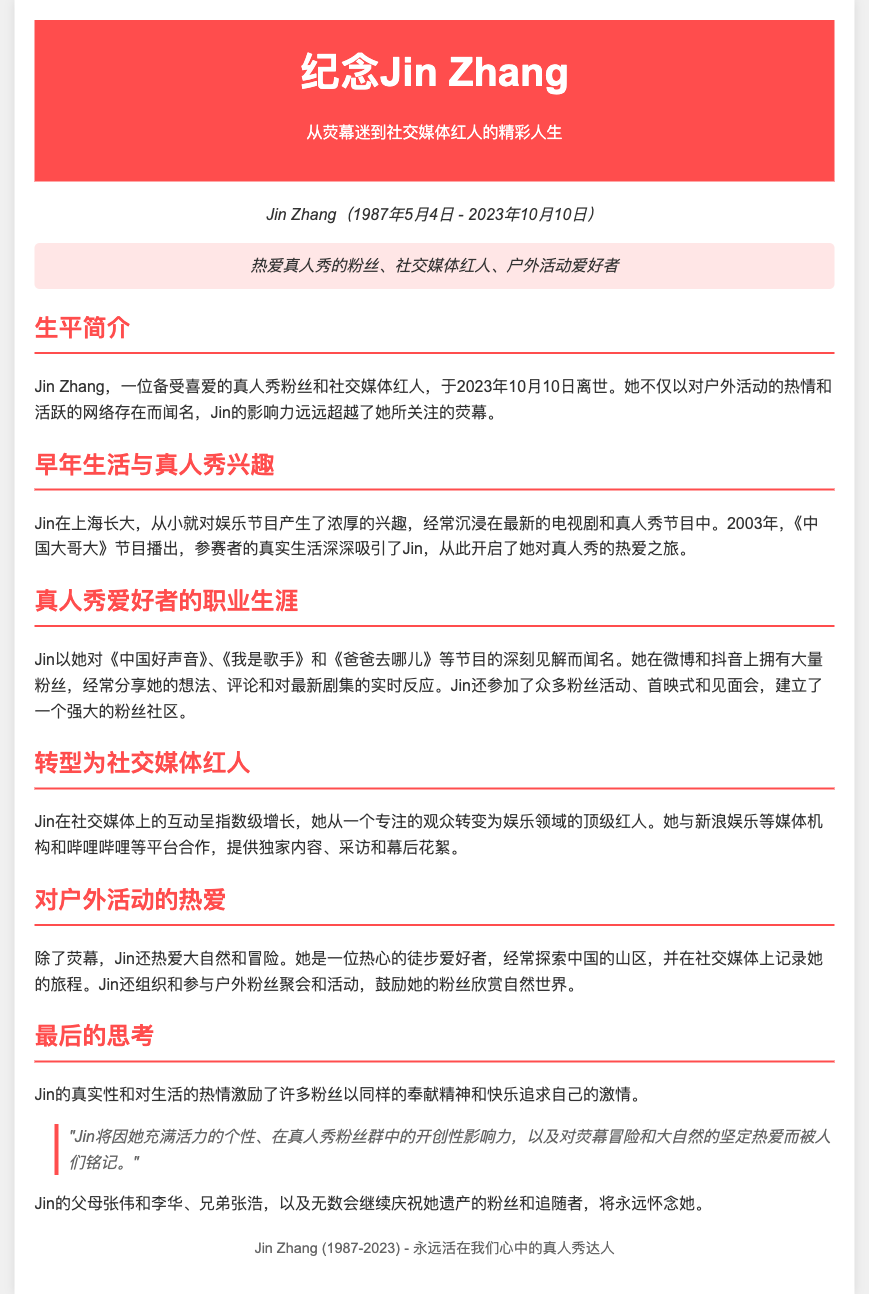什么是Jin Zhang的出生日期？ Jin Zhang的出生日期在文档的开头部分提到，即1987年5月4日。
Answer: 1987年5月4日 Jin Zhang于哪一天去世？ Jin Zhang的去世日期在文档中明确指出，即2023年10月10日。
Answer: 2023年10月10日 Jin Zhang是在哪个城市长大的？ 文档的早年生活部分提到Jin Zhang在上海长大。
Answer: 上海 Jin Zhang的父母名字是什么？ 在最后的思考部分提到Jin的父母是张伟和李华。
Answer: 张伟和李华 Jin Zhang因何种节目而开始对真人秀的热爱？ 文档提到《中国大哥大》节目启发了Jin对真人秀的热爱。
Answer: 中国大哥大 Jin Zhang在社交媒体上最常分享哪些内容？ 她在社交媒体上分享她的想法、评论和对最新剧集的实时反应。
Answer: 想法、评论和实时反应 Jin Zhang最喜欢的户外活动是什么？ 文档提到Jin Zhang是一位热心的徒步爱好者。
Answer: 徒步 Jin Zhang的影响力在社交媒体上如何变化？ 文档提到Jin从一个专注的观众转变为娱乐领域的顶级红人。
Answer: 顶级红人 Jin Zhang的遗产将如何被人们铭记？ 文档最后提到她的个性、影响力和对生活的热情将使她被人们铭记。
Answer: 个性、影响力和对生活的热情 